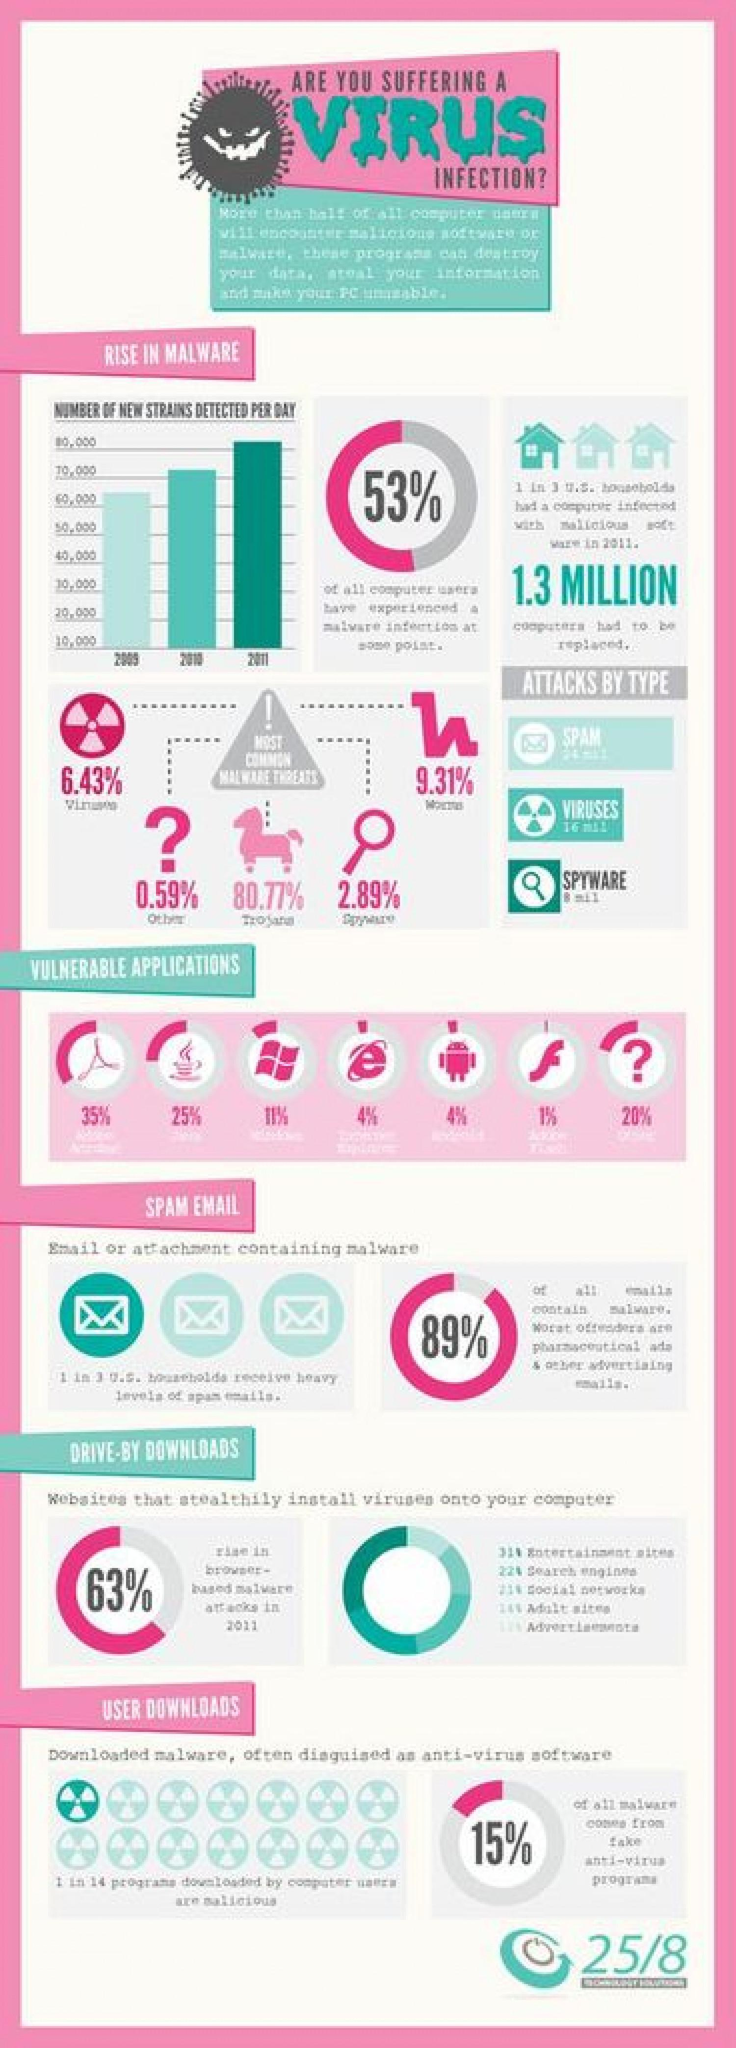Identify some key points in this picture. The virus represented by the horse is Trojan. It is estimated that approximately 47% of computer users have not experienced a malware infection at some point. During the years 2010 and 2011, a new strain of the virus was detected at a rate of more than 70,000 per day. 